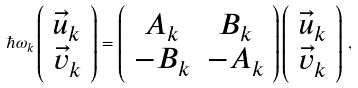<formula> <loc_0><loc_0><loc_500><loc_500>\hbar { \omega } _ { k } \left ( \begin{array} { c } \vec { u } _ { k } \\ \vec { v } _ { k } \end{array} \right ) = \left ( \begin{array} { c c } A _ { k } & B _ { k } \\ - B _ { k } & - A _ { k } \end{array} \right ) \left ( \begin{array} { c } \vec { u } _ { k } \\ \vec { v } _ { k } \end{array} \right ) \, ,</formula> 